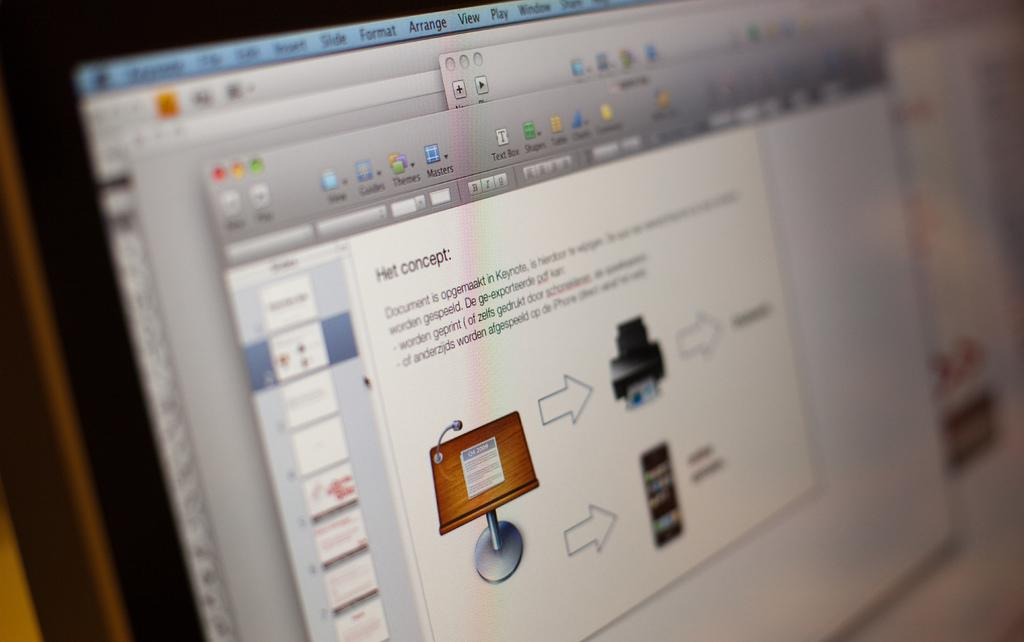<image>
Provide a brief description of the given image. Computer Screen that says: Het Concept: Document is opgemaakrt in Keynote. 